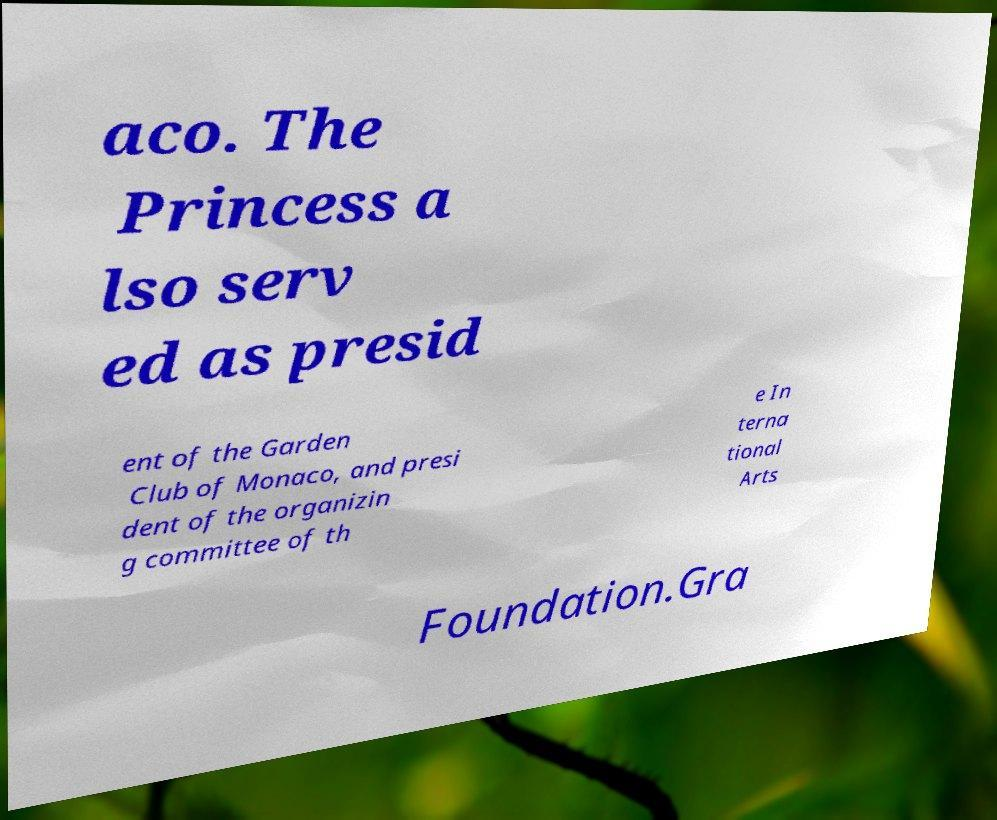There's text embedded in this image that I need extracted. Can you transcribe it verbatim? aco. The Princess a lso serv ed as presid ent of the Garden Club of Monaco, and presi dent of the organizin g committee of th e In terna tional Arts Foundation.Gra 